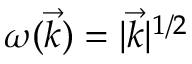Convert formula to latex. <formula><loc_0><loc_0><loc_500><loc_500>\omega ( \vec { k } ) = | \vec { k } | ^ { 1 / 2 }</formula> 